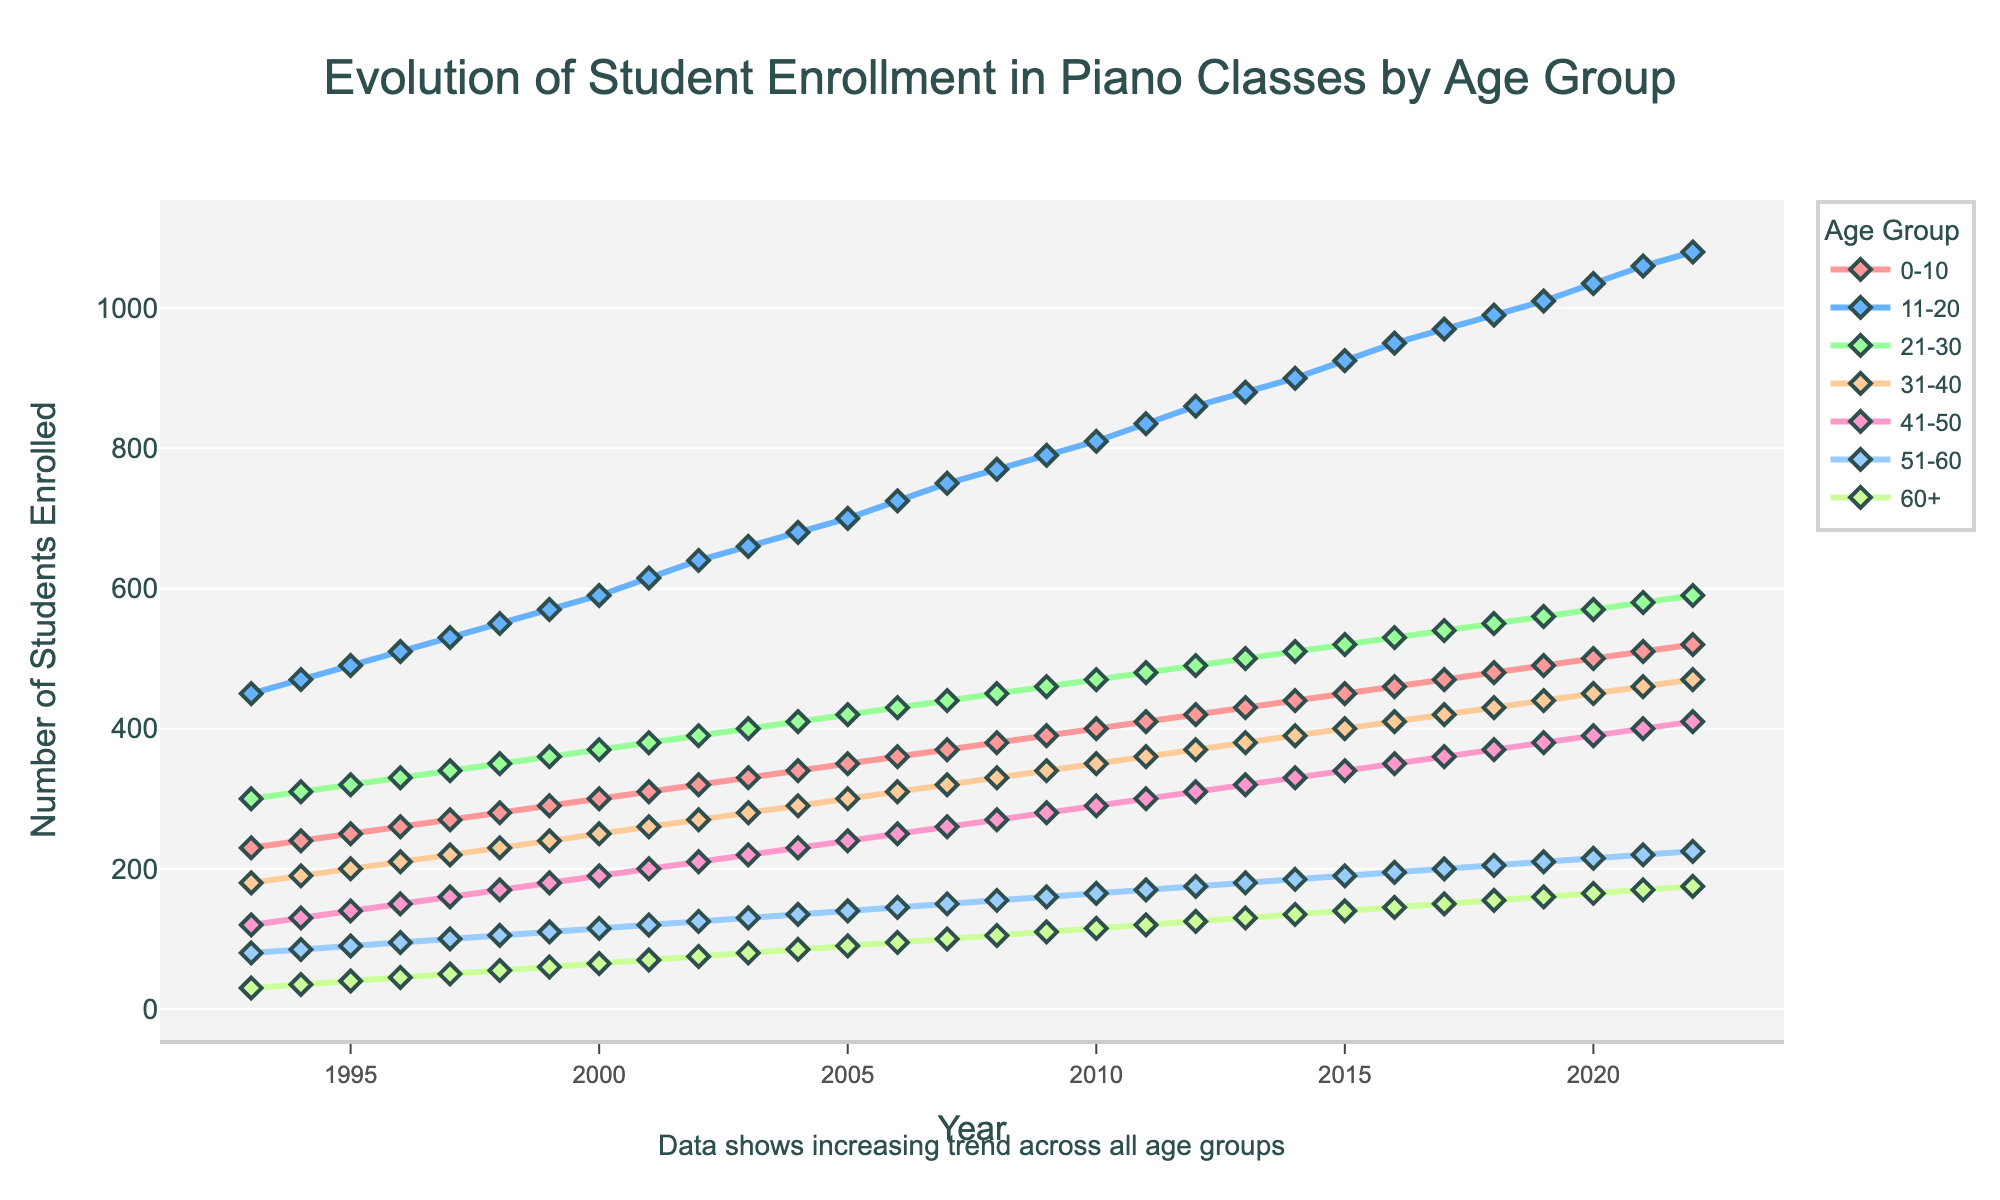what is the title of the figure? The title is located at the top of the chart and provides the main idea of the plot: "Evolution of Student Enrollment in Piano Classes by Age Group".
Answer: Evolution of Student Enrollment in Piano Classes by Age Group How many age groups are depicted in the figure? The legend on the right-hand side lists all age groups, and counting them reveals there are 7 age groups.
Answer: 7 Which age group had the highest increase in student enrollment from 1993 to 2022? To determine this, compare the enrollment numbers of each age group in 1993 and 2022 and find the group with the largest difference. The 11-20 age group increased from 450 to 1080, which is the highest increase of 630 students.
Answer: 11-20 Is there any age group where student enrollment decreased over the years? Observing the trend lines for each age group, no lines show a downward trajectory; all lines have an upward trend.
Answer: No What is the overall trend observed in the student enrollment over the three decades? By examining the annotations and general upward movement of the lines for each age group, it is clear that all age groups show an increasing trend in student enrollment.
Answer: Increasing Of the age groups shown, which had the least number of students enrolled in 1993, and how many were there? Refer to the point for the year 1993 and find the minimum value in the lines. The 60+ age group had the least number of students, with 30 students.
Answer: 60+, 30 How does the enrollment for the 21-30 age group in 2010 compare to the 41-50 age group in 2020? Look at the points for the 21-30 age group in 2010 and compare it to the 41-50 age group in 2020. 21-30 had 470 students in 2010, while 41-50 had 390 students in 2020.
Answer: 21-30 in 2010 had more students Can you calculate the average number of students enrolled across all age groups in 2005? Sum the number of students for all age groups in 2005 and divide by the number of age groups: (350 + 700 + 420 + 300 + 240 + 140 + 90)/7 = 2200/7 ≈ 314.29 students.
Answer: ≈ 314.29 Which age group had the smallest increase in student enrollment from 2010 to 2022? Subtract the number of enrollments in 2010 from the enrollments in 2022 for each age group and find the smallest difference. The 60+ age group had the smallest increase of 165 - 115 = 50 students.
Answer: 60+, 50 Which year saw the highest enrollment for the 31-40 age group? By following the trend line for 31-40, the highest point is at the year 2022 with 470 enrollments.
Answer: 2022 